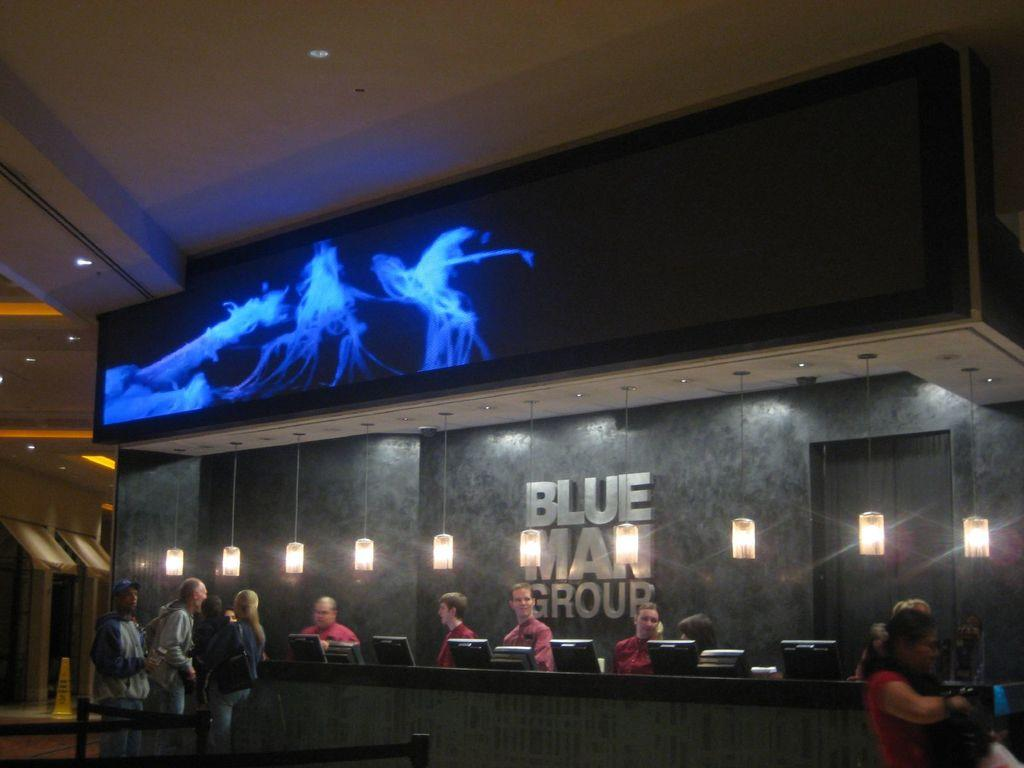What is happening in the image? There are people standing in the image. What objects are on the table in the image? There are desktops on a table in the image. What can be seen in the background of the image? There are lights visible in the background of the image. What is at the top of the image? There is a screen at the top of the image. What type of eggs are being cooked by the sister in the image? There is no sister or eggs present in the image. 